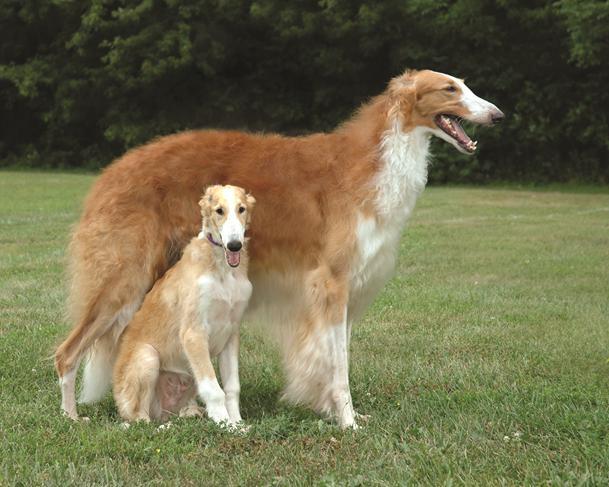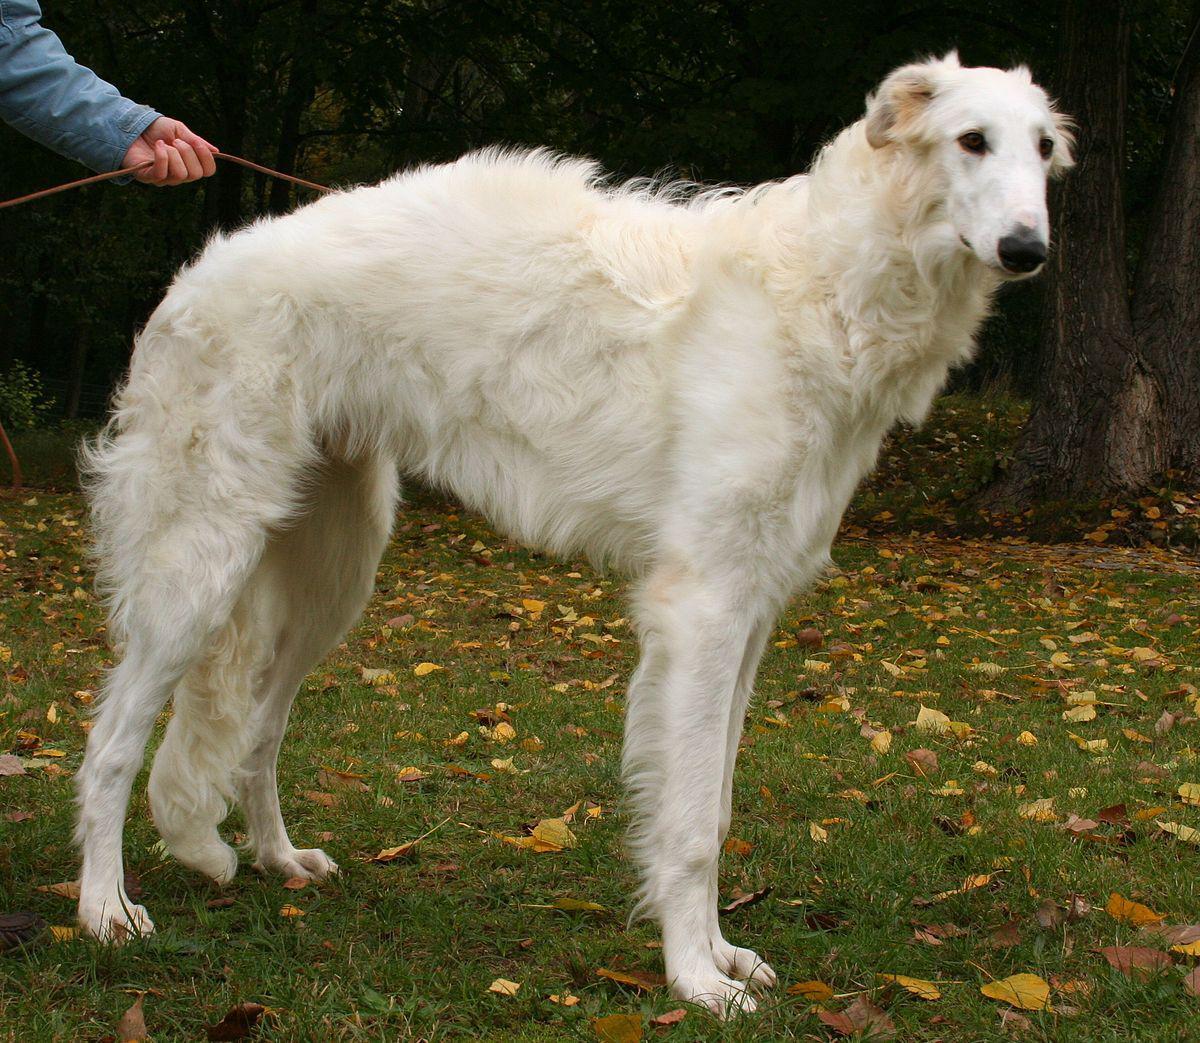The first image is the image on the left, the second image is the image on the right. For the images shown, is this caption "An image shows exactly two hounds." true? Answer yes or no. Yes. 